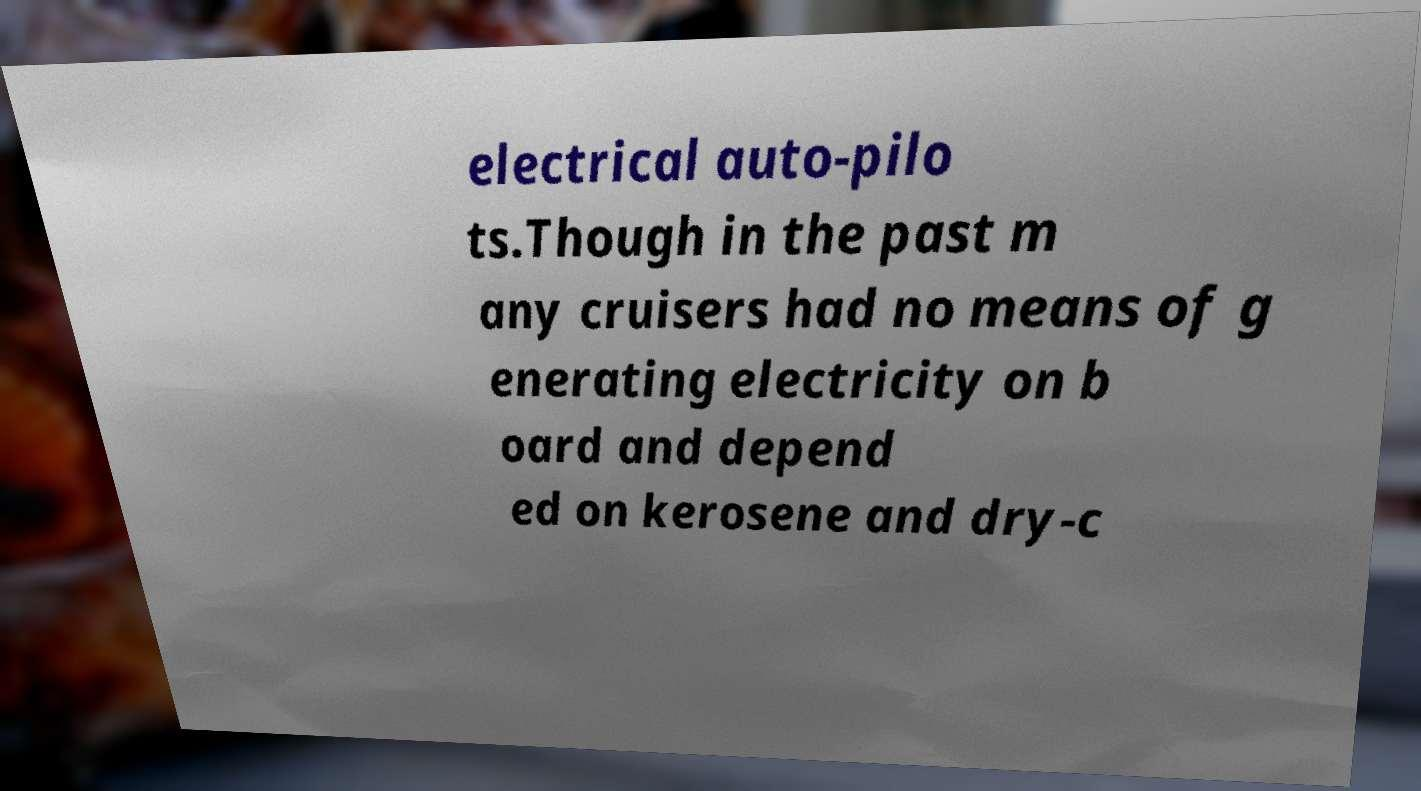Could you extract and type out the text from this image? electrical auto-pilo ts.Though in the past m any cruisers had no means of g enerating electricity on b oard and depend ed on kerosene and dry-c 